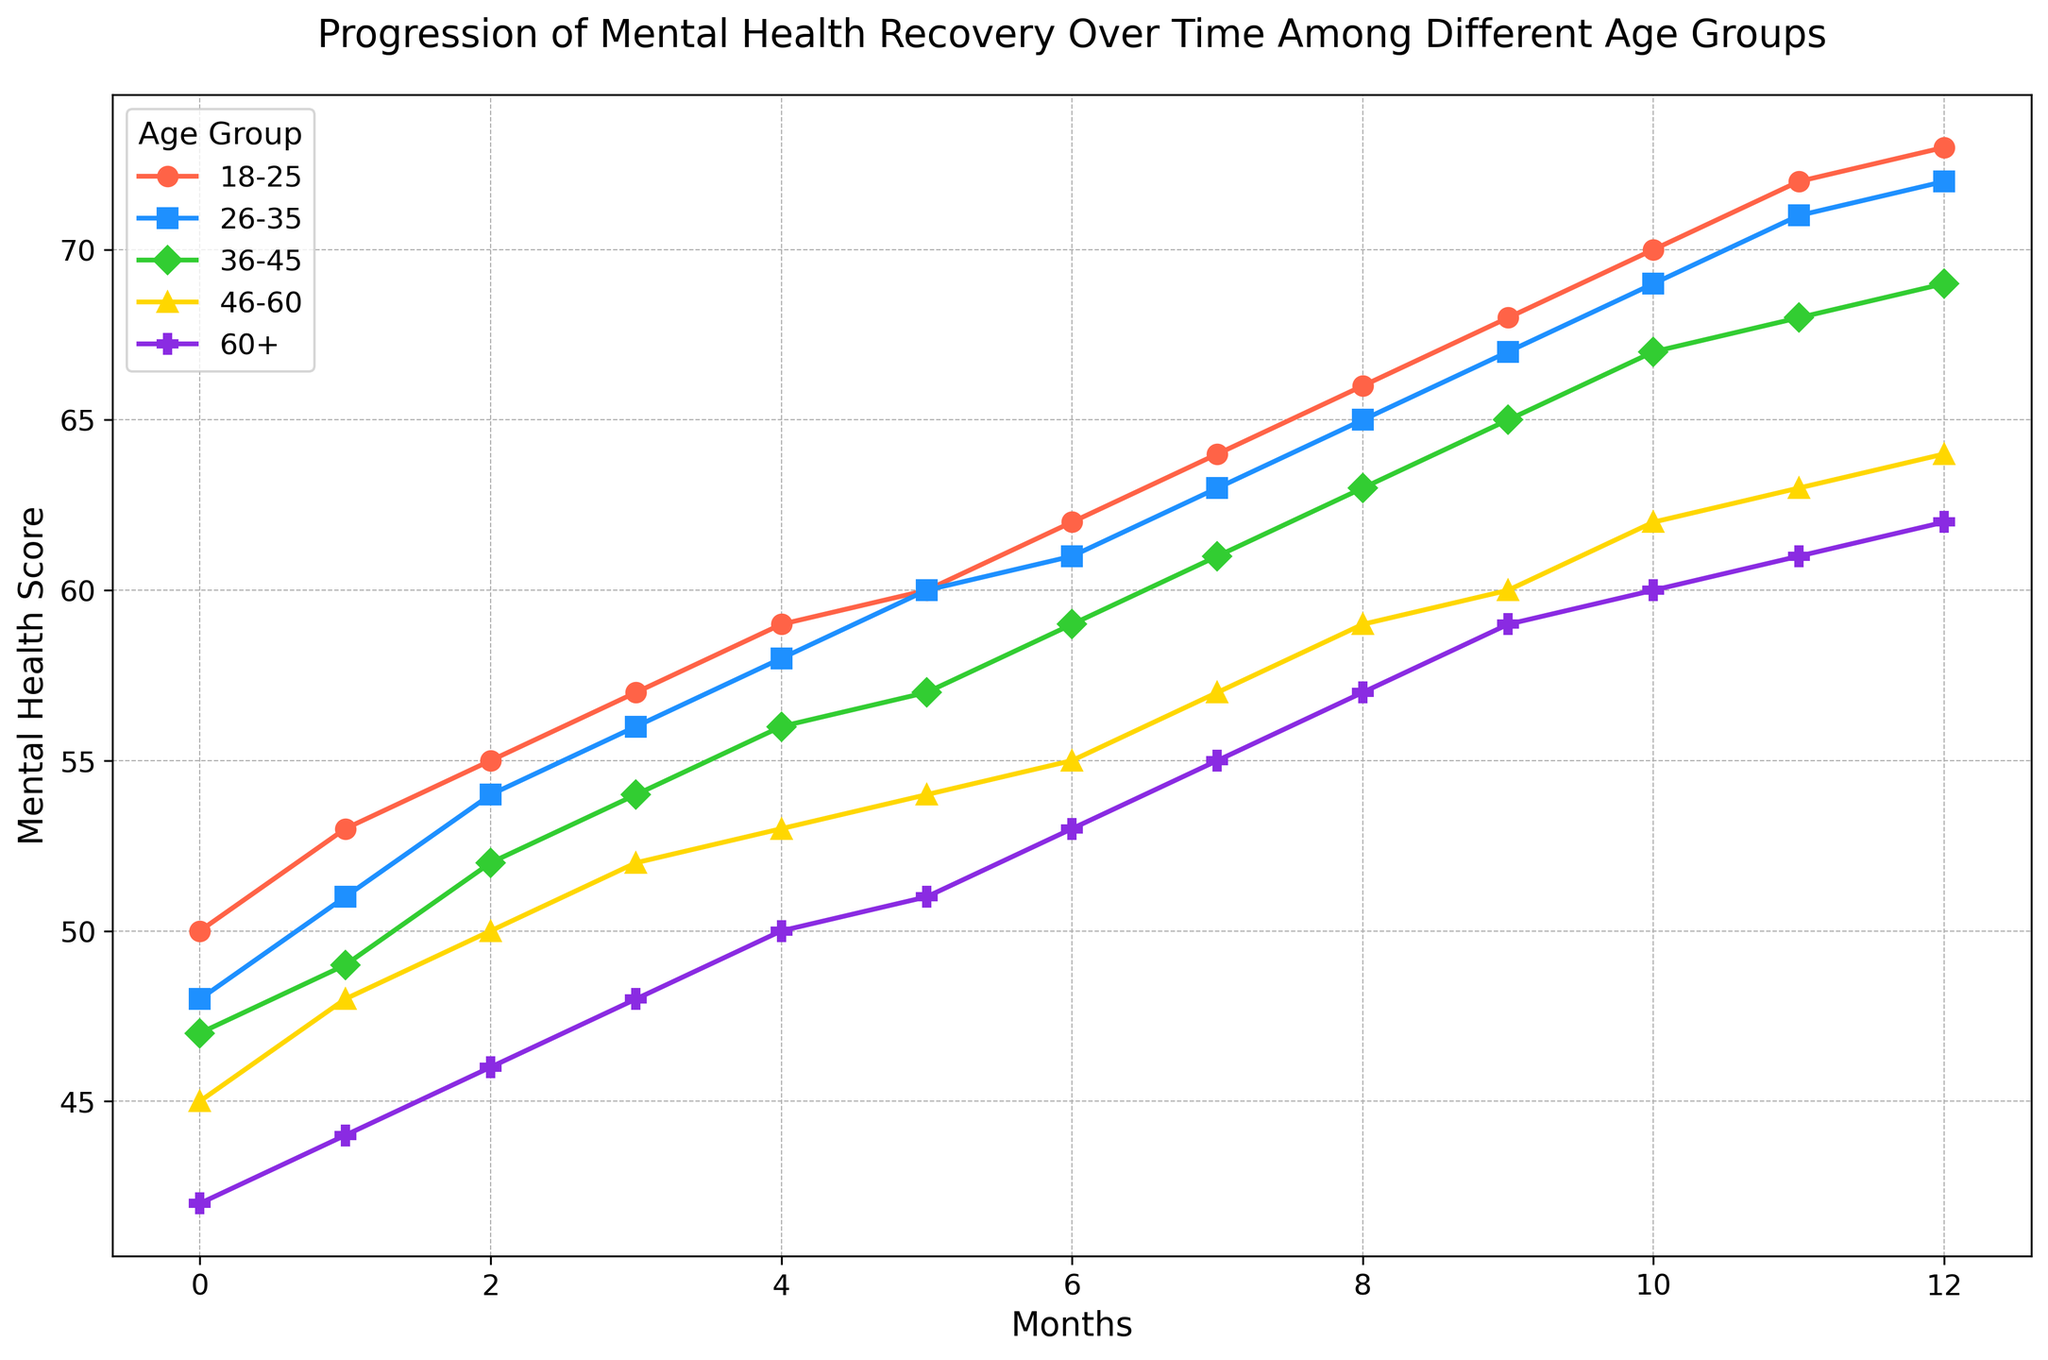How much does the mental health score improve for the 18-25 age group from month 0 to month 12? To find this, subtract the mental health score at month 0 from the score at month 12 for the 18-25 age group. The initial score is 50 and the final score is 73. So, 73 - 50 = 23
Answer: 23 Which age group shows the least improvement in mental health score over the 12 months? Calculate the difference between month 0 and month 12 for each age group and compare them. For 18-25, the improvement is 73-50=23. For 26-35, it's 72-48=24. For 36-45, it's 69-47=22. For 46-60, it's 64-45=19. For 60+, it's 62-42=20. The least improvement is seen in the 46-60 age group with a difference of 19
Answer: 46-60 Among the age groups, which one starts with the highest mental health score at month 0? Examine the mental health scores at month 0 for all age groups. The scores are 50, 48, 47, 45, and 42 respectively for 18-25, 26-35, 36-45, 46-60, and 60+. The highest initial score is 50 for the 18-25 age group
Answer: 18-25 What is the average mental health score improvement for all age groups combined over the 12-month period? First, find the improvement for each age group: 18-25 (23), 26-35 (24), 36-45 (22), 46-60 (19), and 60+ (20). Sum these improvements: 23 + 24 + 22 + 19 + 20 = 108. Divide by the number of age groups, 108/5 = 21.6
Answer: 21.6 Which age group shows a consistent improvement without any plateau or decline over the 12 months? Observe each line on the chart for consistent upward trends without any flat or downward sections. The 18-25 age group shows a consistent improvement every month
Answer: 18-25 At which month does the 36-45 age group’s mental health score reach 65? Look at the month axis and find the point where the 36-45 line intersects the mental health score of 65. It happens at month 9
Answer: 9 By the end of the 12 months, which age groups have mental health scores that are within 2 points of each other? Compare the final mental health scores at month 12: 73 (18-25), 72 (26-35), 69 (36-45), 64 (46-60), 62 (60+). The scores of 18-25 and 26-35 are within 1 point of each other
Answer: 18-25 and 26-35 Which age group shows the highest monthly improvement rate on average? Calculate the average monthly improvement (total improvement/months): 18-25 (23/12=1.92), 26-35 (24/12=2), 36-45 (22/12=1.83), 46-60 (19/12=1.58), 60+ (20/12=1.67). The highest average monthly improvement rate is for the 26-35 age group at 2 points per month
Answer: 26-35 